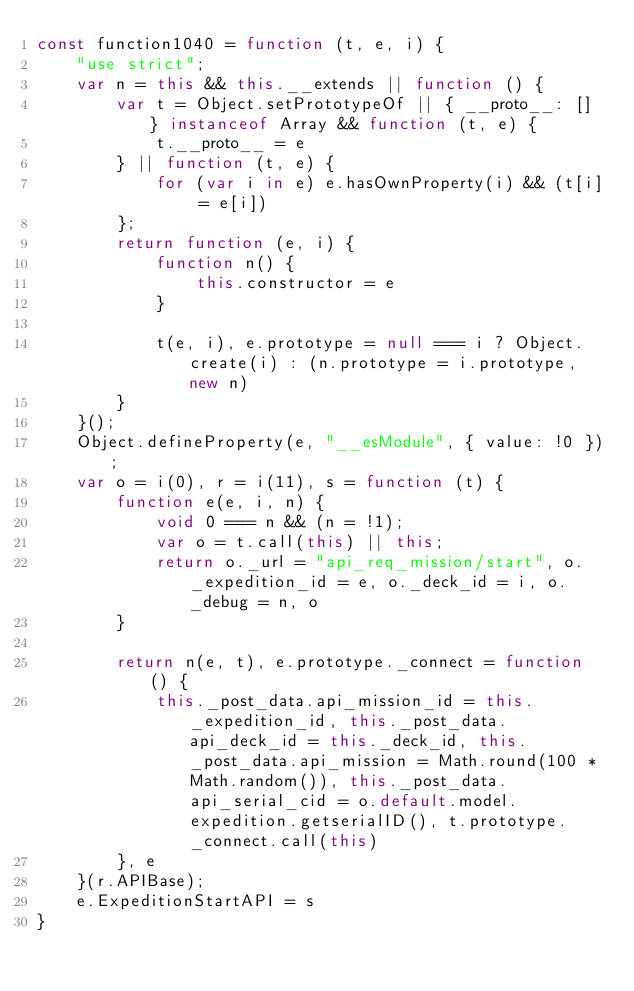Convert code to text. <code><loc_0><loc_0><loc_500><loc_500><_JavaScript_>const function1040 = function (t, e, i) {
    "use strict";
    var n = this && this.__extends || function () {
        var t = Object.setPrototypeOf || { __proto__: [] } instanceof Array && function (t, e) {
            t.__proto__ = e
        } || function (t, e) {
            for (var i in e) e.hasOwnProperty(i) && (t[i] = e[i])
        };
        return function (e, i) {
            function n() {
                this.constructor = e
            }

            t(e, i), e.prototype = null === i ? Object.create(i) : (n.prototype = i.prototype, new n)
        }
    }();
    Object.defineProperty(e, "__esModule", { value: !0 });
    var o = i(0), r = i(11), s = function (t) {
        function e(e, i, n) {
            void 0 === n && (n = !1);
            var o = t.call(this) || this;
            return o._url = "api_req_mission/start", o._expedition_id = e, o._deck_id = i, o._debug = n, o
        }

        return n(e, t), e.prototype._connect = function () {
            this._post_data.api_mission_id = this._expedition_id, this._post_data.api_deck_id = this._deck_id, this._post_data.api_mission = Math.round(100 * Math.random()), this._post_data.api_serial_cid = o.default.model.expedition.getserialID(), t.prototype._connect.call(this)
        }, e
    }(r.APIBase);
    e.ExpeditionStartAPI = s
}</code> 